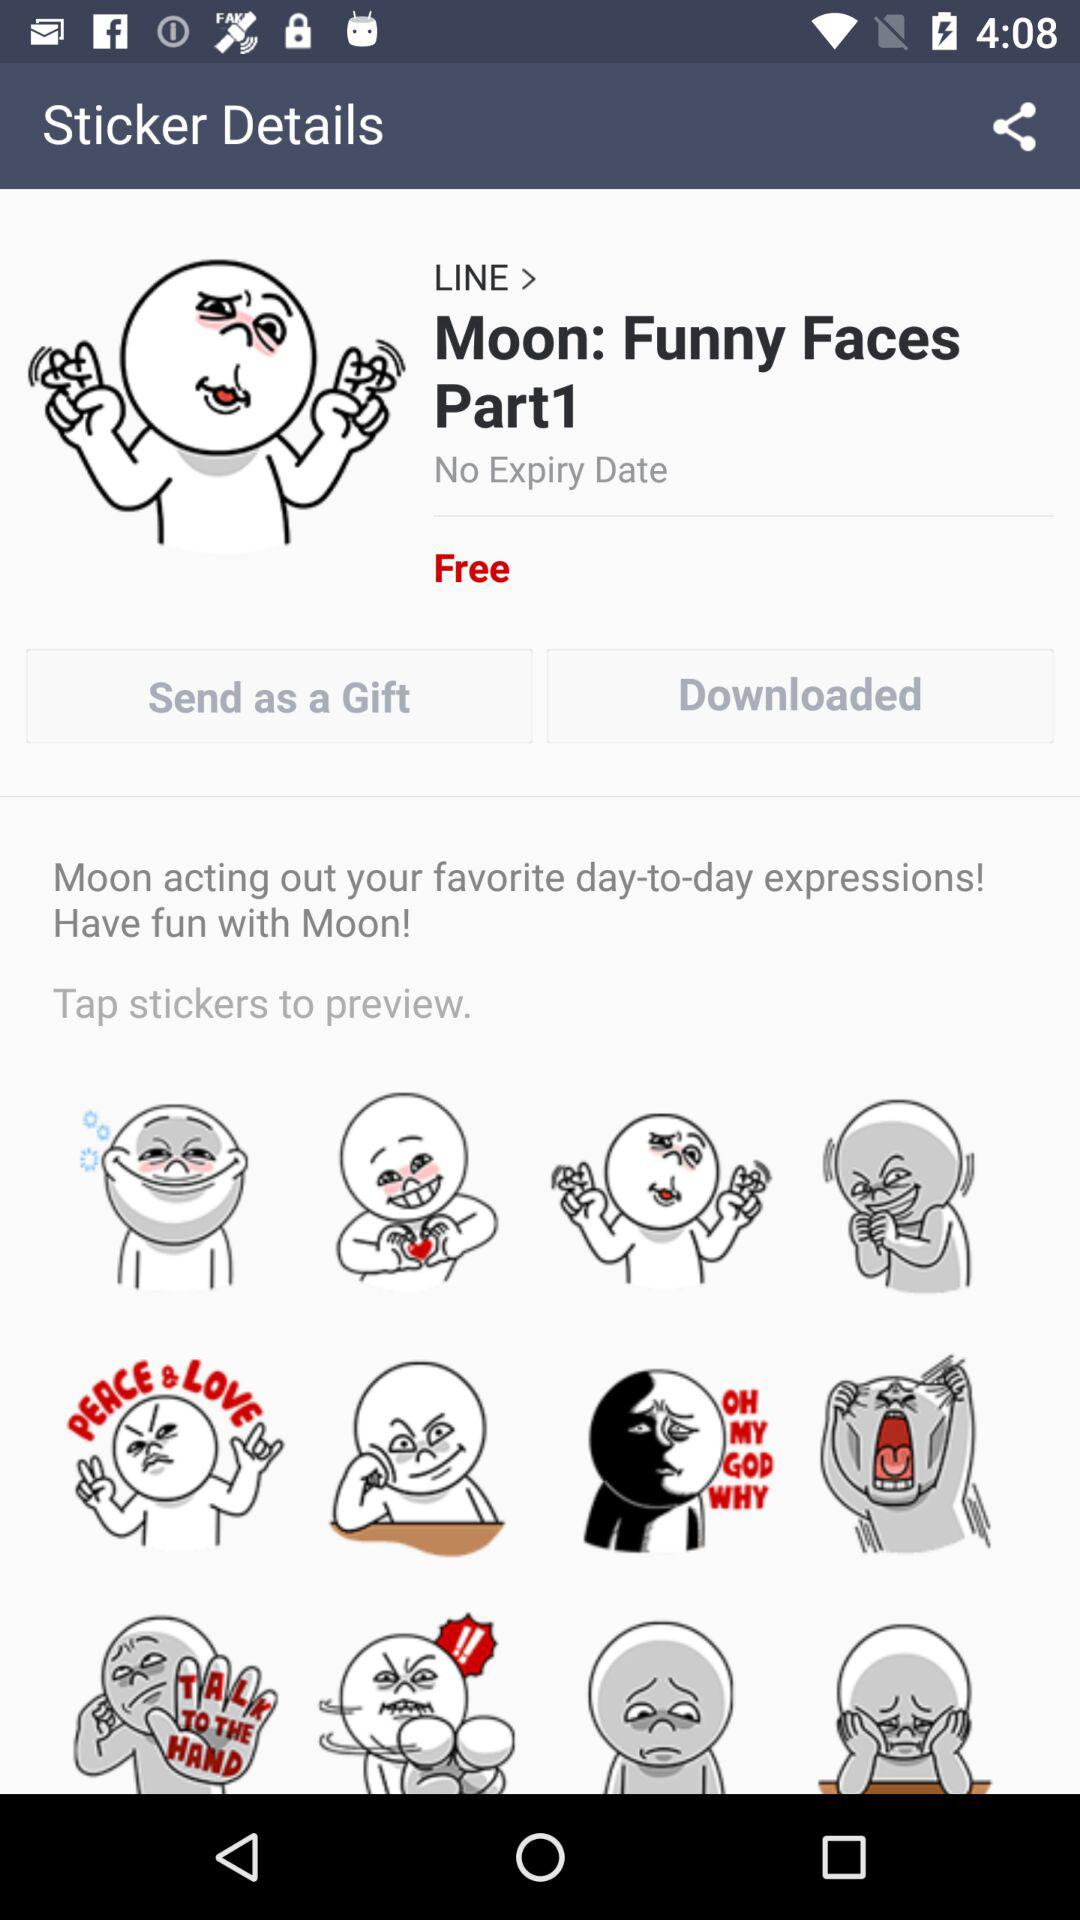Is the "Moon: Funny Faces Part1" sticker free or paid? The "Moon: Funny Faces Part1" sticker is free. 